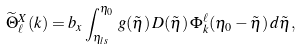Convert formula to latex. <formula><loc_0><loc_0><loc_500><loc_500>\widetilde { \Theta } _ { \ell } ^ { X } ( k ) = b _ { x } \int _ { \eta _ { l s } } ^ { \eta _ { 0 } } \, g ( \tilde { \eta } ) \, D ( \tilde { \eta } ) \, \Phi _ { k } ^ { \ell } ( \eta _ { 0 } - \tilde { \eta } ) \, d \tilde { \eta } ,</formula> 